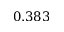<formula> <loc_0><loc_0><loc_500><loc_500>0 . 3 8 3</formula> 